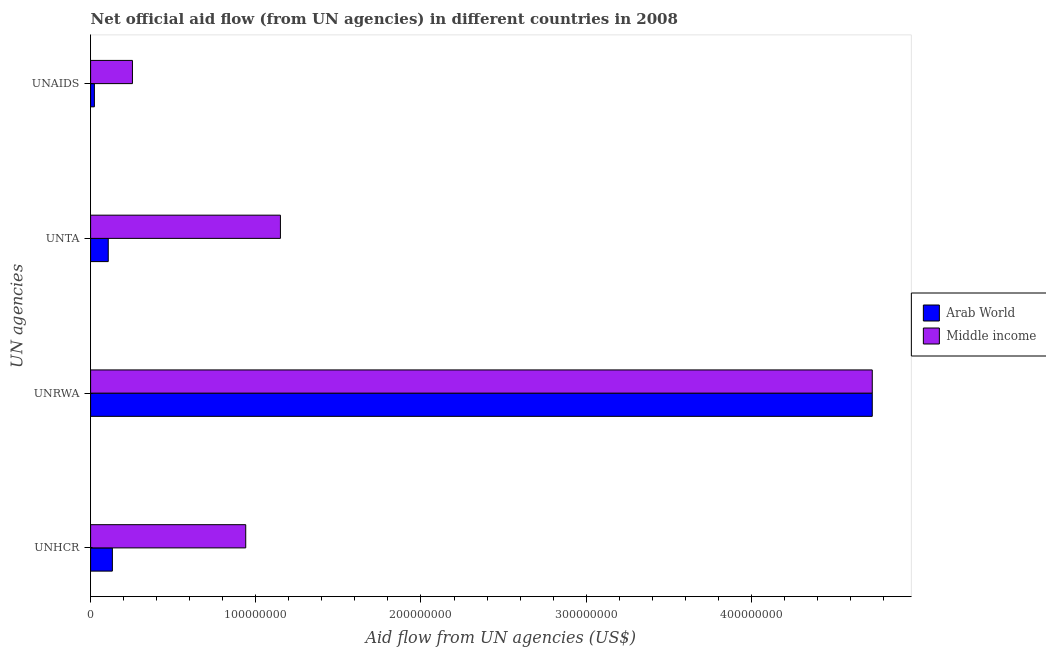How many different coloured bars are there?
Offer a terse response. 2. How many groups of bars are there?
Give a very brief answer. 4. Are the number of bars on each tick of the Y-axis equal?
Ensure brevity in your answer.  Yes. What is the label of the 2nd group of bars from the top?
Offer a terse response. UNTA. What is the amount of aid given by unta in Middle income?
Provide a short and direct response. 1.15e+08. Across all countries, what is the maximum amount of aid given by unhcr?
Give a very brief answer. 9.39e+07. Across all countries, what is the minimum amount of aid given by unta?
Ensure brevity in your answer.  1.07e+07. In which country was the amount of aid given by unta minimum?
Keep it short and to the point. Arab World. What is the total amount of aid given by unta in the graph?
Offer a terse response. 1.26e+08. What is the difference between the amount of aid given by unta in Arab World and that in Middle income?
Provide a succinct answer. -1.04e+08. What is the difference between the amount of aid given by unta in Middle income and the amount of aid given by unrwa in Arab World?
Offer a terse response. -3.58e+08. What is the average amount of aid given by unaids per country?
Give a very brief answer. 1.38e+07. What is the difference between the amount of aid given by unaids and amount of aid given by unrwa in Arab World?
Make the answer very short. -4.71e+08. What is the ratio of the amount of aid given by unta in Arab World to that in Middle income?
Provide a short and direct response. 0.09. Is the difference between the amount of aid given by unaids in Arab World and Middle income greater than the difference between the amount of aid given by unhcr in Arab World and Middle income?
Your answer should be very brief. Yes. What is the difference between the highest and the second highest amount of aid given by unta?
Give a very brief answer. 1.04e+08. What is the difference between the highest and the lowest amount of aid given by unta?
Give a very brief answer. 1.04e+08. Is the sum of the amount of aid given by unta in Middle income and Arab World greater than the maximum amount of aid given by unhcr across all countries?
Your answer should be very brief. Yes. Is it the case that in every country, the sum of the amount of aid given by unaids and amount of aid given by unhcr is greater than the sum of amount of aid given by unta and amount of aid given by unrwa?
Give a very brief answer. No. What does the 2nd bar from the top in UNRWA represents?
Your answer should be very brief. Arab World. What does the 1st bar from the bottom in UNAIDS represents?
Your answer should be very brief. Arab World. How many bars are there?
Provide a short and direct response. 8. Are all the bars in the graph horizontal?
Provide a succinct answer. Yes. Does the graph contain grids?
Your answer should be very brief. No. Where does the legend appear in the graph?
Ensure brevity in your answer.  Center right. How many legend labels are there?
Give a very brief answer. 2. What is the title of the graph?
Provide a short and direct response. Net official aid flow (from UN agencies) in different countries in 2008. Does "Gambia, The" appear as one of the legend labels in the graph?
Make the answer very short. No. What is the label or title of the X-axis?
Your response must be concise. Aid flow from UN agencies (US$). What is the label or title of the Y-axis?
Keep it short and to the point. UN agencies. What is the Aid flow from UN agencies (US$) of Arab World in UNHCR?
Ensure brevity in your answer.  1.32e+07. What is the Aid flow from UN agencies (US$) of Middle income in UNHCR?
Make the answer very short. 9.39e+07. What is the Aid flow from UN agencies (US$) in Arab World in UNRWA?
Your answer should be compact. 4.73e+08. What is the Aid flow from UN agencies (US$) of Middle income in UNRWA?
Give a very brief answer. 4.73e+08. What is the Aid flow from UN agencies (US$) of Arab World in UNTA?
Your answer should be compact. 1.07e+07. What is the Aid flow from UN agencies (US$) in Middle income in UNTA?
Keep it short and to the point. 1.15e+08. What is the Aid flow from UN agencies (US$) of Arab World in UNAIDS?
Provide a short and direct response. 2.28e+06. What is the Aid flow from UN agencies (US$) of Middle income in UNAIDS?
Your answer should be compact. 2.53e+07. Across all UN agencies, what is the maximum Aid flow from UN agencies (US$) of Arab World?
Provide a succinct answer. 4.73e+08. Across all UN agencies, what is the maximum Aid flow from UN agencies (US$) of Middle income?
Your answer should be compact. 4.73e+08. Across all UN agencies, what is the minimum Aid flow from UN agencies (US$) in Arab World?
Your response must be concise. 2.28e+06. Across all UN agencies, what is the minimum Aid flow from UN agencies (US$) of Middle income?
Offer a very short reply. 2.53e+07. What is the total Aid flow from UN agencies (US$) of Arab World in the graph?
Your answer should be very brief. 4.99e+08. What is the total Aid flow from UN agencies (US$) in Middle income in the graph?
Your answer should be compact. 7.07e+08. What is the difference between the Aid flow from UN agencies (US$) in Arab World in UNHCR and that in UNRWA?
Your answer should be very brief. -4.60e+08. What is the difference between the Aid flow from UN agencies (US$) of Middle income in UNHCR and that in UNRWA?
Keep it short and to the point. -3.79e+08. What is the difference between the Aid flow from UN agencies (US$) of Arab World in UNHCR and that in UNTA?
Provide a short and direct response. 2.50e+06. What is the difference between the Aid flow from UN agencies (US$) of Middle income in UNHCR and that in UNTA?
Offer a very short reply. -2.10e+07. What is the difference between the Aid flow from UN agencies (US$) of Arab World in UNHCR and that in UNAIDS?
Your answer should be very brief. 1.09e+07. What is the difference between the Aid flow from UN agencies (US$) in Middle income in UNHCR and that in UNAIDS?
Provide a succinct answer. 6.86e+07. What is the difference between the Aid flow from UN agencies (US$) of Arab World in UNRWA and that in UNTA?
Your response must be concise. 4.63e+08. What is the difference between the Aid flow from UN agencies (US$) in Middle income in UNRWA and that in UNTA?
Give a very brief answer. 3.58e+08. What is the difference between the Aid flow from UN agencies (US$) of Arab World in UNRWA and that in UNAIDS?
Make the answer very short. 4.71e+08. What is the difference between the Aid flow from UN agencies (US$) in Middle income in UNRWA and that in UNAIDS?
Make the answer very short. 4.48e+08. What is the difference between the Aid flow from UN agencies (US$) in Arab World in UNTA and that in UNAIDS?
Make the answer very short. 8.40e+06. What is the difference between the Aid flow from UN agencies (US$) in Middle income in UNTA and that in UNAIDS?
Ensure brevity in your answer.  8.96e+07. What is the difference between the Aid flow from UN agencies (US$) of Arab World in UNHCR and the Aid flow from UN agencies (US$) of Middle income in UNRWA?
Your answer should be compact. -4.60e+08. What is the difference between the Aid flow from UN agencies (US$) in Arab World in UNHCR and the Aid flow from UN agencies (US$) in Middle income in UNTA?
Provide a succinct answer. -1.02e+08. What is the difference between the Aid flow from UN agencies (US$) in Arab World in UNHCR and the Aid flow from UN agencies (US$) in Middle income in UNAIDS?
Give a very brief answer. -1.21e+07. What is the difference between the Aid flow from UN agencies (US$) in Arab World in UNRWA and the Aid flow from UN agencies (US$) in Middle income in UNTA?
Give a very brief answer. 3.58e+08. What is the difference between the Aid flow from UN agencies (US$) in Arab World in UNRWA and the Aid flow from UN agencies (US$) in Middle income in UNAIDS?
Keep it short and to the point. 4.48e+08. What is the difference between the Aid flow from UN agencies (US$) in Arab World in UNTA and the Aid flow from UN agencies (US$) in Middle income in UNAIDS?
Make the answer very short. -1.46e+07. What is the average Aid flow from UN agencies (US$) in Arab World per UN agencies?
Offer a very short reply. 1.25e+08. What is the average Aid flow from UN agencies (US$) of Middle income per UN agencies?
Your answer should be compact. 1.77e+08. What is the difference between the Aid flow from UN agencies (US$) of Arab World and Aid flow from UN agencies (US$) of Middle income in UNHCR?
Offer a very short reply. -8.07e+07. What is the difference between the Aid flow from UN agencies (US$) in Arab World and Aid flow from UN agencies (US$) in Middle income in UNRWA?
Offer a terse response. 0. What is the difference between the Aid flow from UN agencies (US$) of Arab World and Aid flow from UN agencies (US$) of Middle income in UNTA?
Give a very brief answer. -1.04e+08. What is the difference between the Aid flow from UN agencies (US$) in Arab World and Aid flow from UN agencies (US$) in Middle income in UNAIDS?
Keep it short and to the point. -2.30e+07. What is the ratio of the Aid flow from UN agencies (US$) of Arab World in UNHCR to that in UNRWA?
Your answer should be compact. 0.03. What is the ratio of the Aid flow from UN agencies (US$) of Middle income in UNHCR to that in UNRWA?
Your response must be concise. 0.2. What is the ratio of the Aid flow from UN agencies (US$) of Arab World in UNHCR to that in UNTA?
Give a very brief answer. 1.23. What is the ratio of the Aid flow from UN agencies (US$) in Middle income in UNHCR to that in UNTA?
Provide a short and direct response. 0.82. What is the ratio of the Aid flow from UN agencies (US$) of Arab World in UNHCR to that in UNAIDS?
Ensure brevity in your answer.  5.78. What is the ratio of the Aid flow from UN agencies (US$) in Middle income in UNHCR to that in UNAIDS?
Offer a terse response. 3.71. What is the ratio of the Aid flow from UN agencies (US$) of Arab World in UNRWA to that in UNTA?
Your answer should be very brief. 44.31. What is the ratio of the Aid flow from UN agencies (US$) of Middle income in UNRWA to that in UNTA?
Provide a succinct answer. 4.12. What is the ratio of the Aid flow from UN agencies (US$) in Arab World in UNRWA to that in UNAIDS?
Your answer should be compact. 207.54. What is the ratio of the Aid flow from UN agencies (US$) of Middle income in UNRWA to that in UNAIDS?
Offer a terse response. 18.69. What is the ratio of the Aid flow from UN agencies (US$) in Arab World in UNTA to that in UNAIDS?
Keep it short and to the point. 4.68. What is the ratio of the Aid flow from UN agencies (US$) of Middle income in UNTA to that in UNAIDS?
Ensure brevity in your answer.  4.54. What is the difference between the highest and the second highest Aid flow from UN agencies (US$) in Arab World?
Your response must be concise. 4.60e+08. What is the difference between the highest and the second highest Aid flow from UN agencies (US$) in Middle income?
Keep it short and to the point. 3.58e+08. What is the difference between the highest and the lowest Aid flow from UN agencies (US$) in Arab World?
Your answer should be compact. 4.71e+08. What is the difference between the highest and the lowest Aid flow from UN agencies (US$) in Middle income?
Provide a succinct answer. 4.48e+08. 